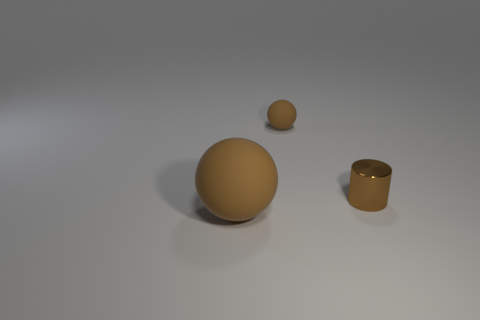Add 2 small metallic objects. How many objects exist? 5 Subtract all balls. How many objects are left? 1 Add 3 spheres. How many spheres exist? 5 Subtract 0 gray spheres. How many objects are left? 3 Subtract all big brown rubber things. Subtract all tiny brown metal cylinders. How many objects are left? 1 Add 1 big brown balls. How many big brown balls are left? 2 